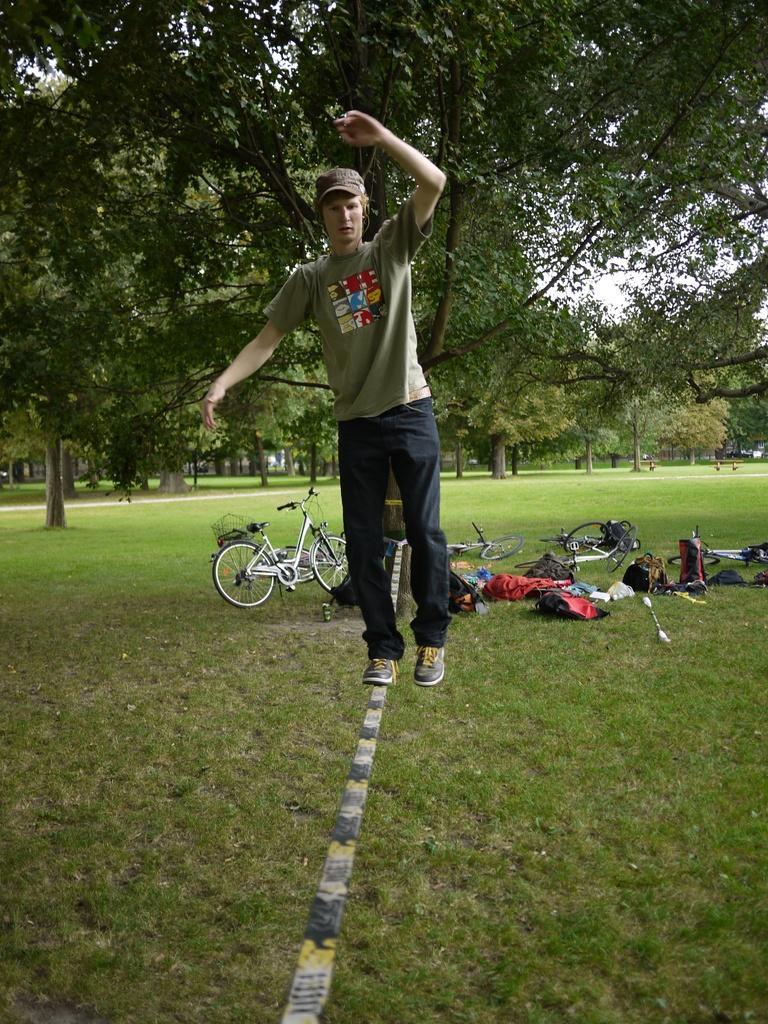How would you summarize this image in a sentence or two? In the middle of the image a man is walking on a rope. Behind him there are some trees and bicycles and bags. Bottom of the image there is grass. 